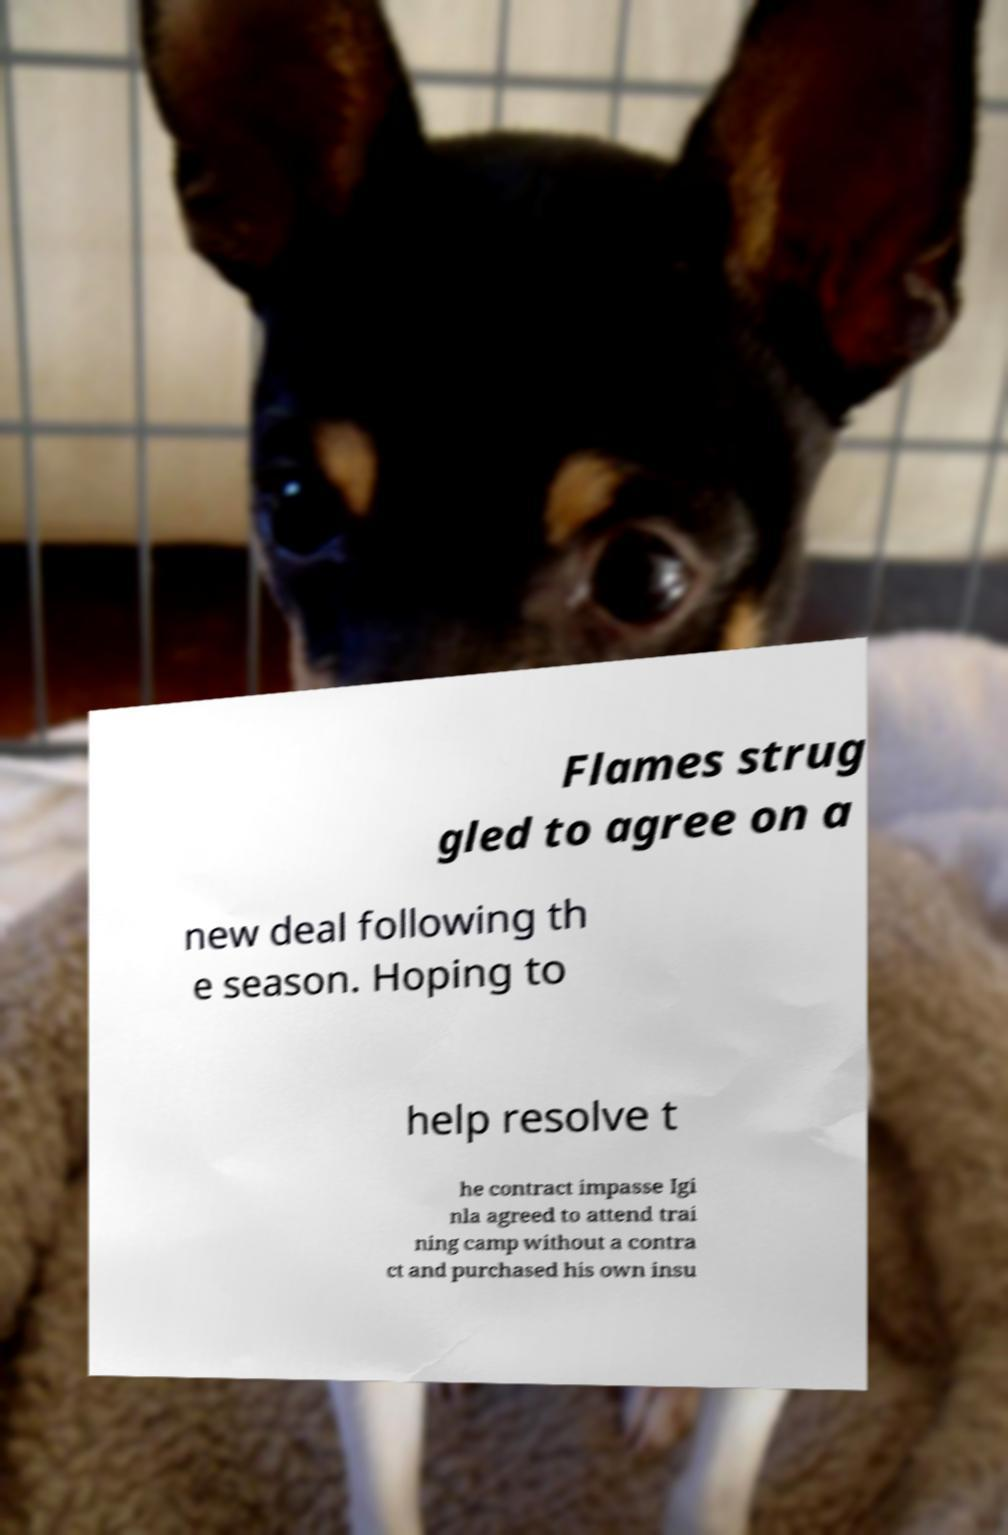Can you read and provide the text displayed in the image?This photo seems to have some interesting text. Can you extract and type it out for me? Flames strug gled to agree on a new deal following th e season. Hoping to help resolve t he contract impasse Igi nla agreed to attend trai ning camp without a contra ct and purchased his own insu 